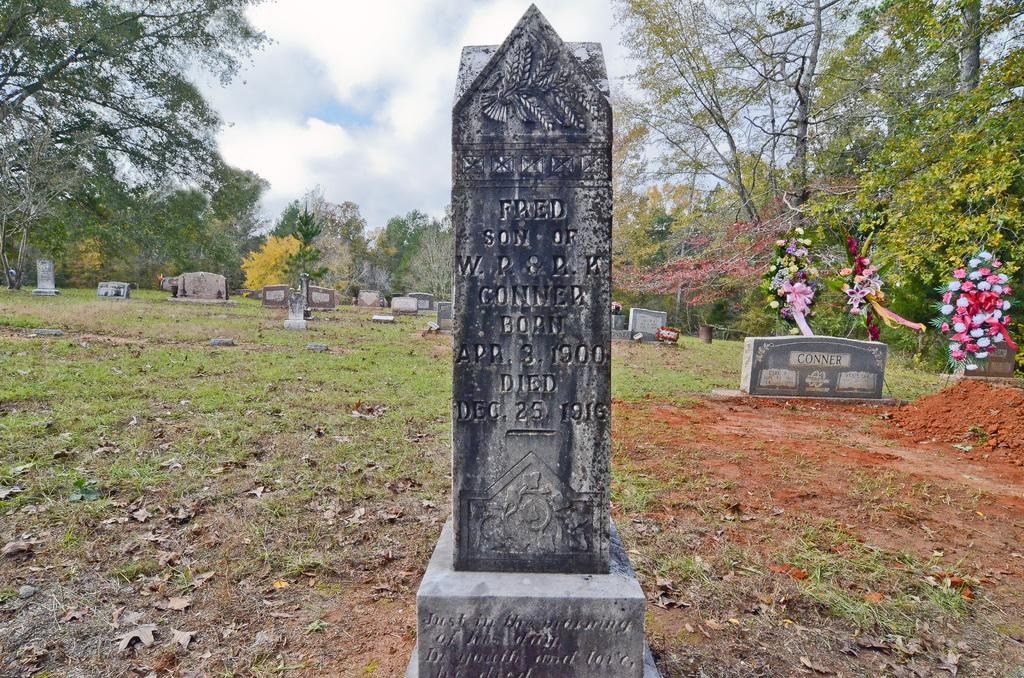What can be seen in the picture? There are gravestones in the picture. What is visible in the background of the picture? In the background, there are flowers, trees, grass, and the sky. Can you describe the natural elements present in the image? The background features trees, grass, and the sky. What type of fruit is hanging from the gravestones in the image? There is no fruit hanging from the gravestones in the image. 